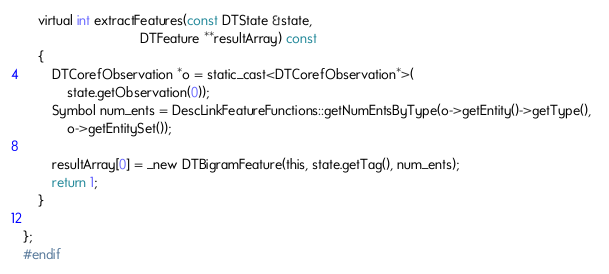Convert code to text. <code><loc_0><loc_0><loc_500><loc_500><_C_>
	virtual int extractFeatures(const DTState &state,
								DTFeature **resultArray) const
	{
		DTCorefObservation *o = static_cast<DTCorefObservation*>(
			state.getObservation(0));
		Symbol num_ents = DescLinkFeatureFunctions::getNumEntsByType(o->getEntity()->getType(),  
			o->getEntitySet());
			
		resultArray[0] = _new DTBigramFeature(this, state.getTag(), num_ents);
		return 1;
	}

};
#endif
</code> 